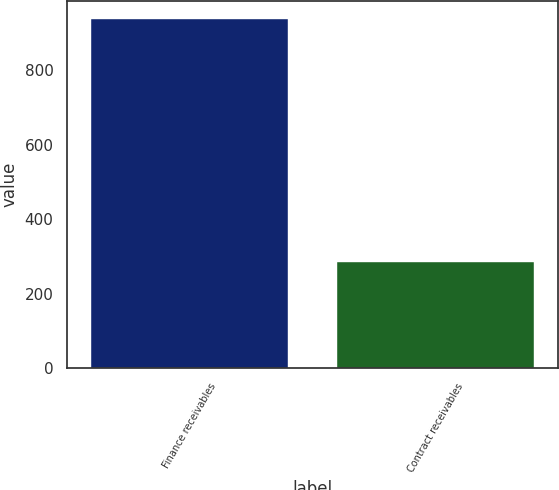Convert chart. <chart><loc_0><loc_0><loc_500><loc_500><bar_chart><fcel>Finance receivables<fcel>Contract receivables<nl><fcel>938.4<fcel>286.1<nl></chart> 